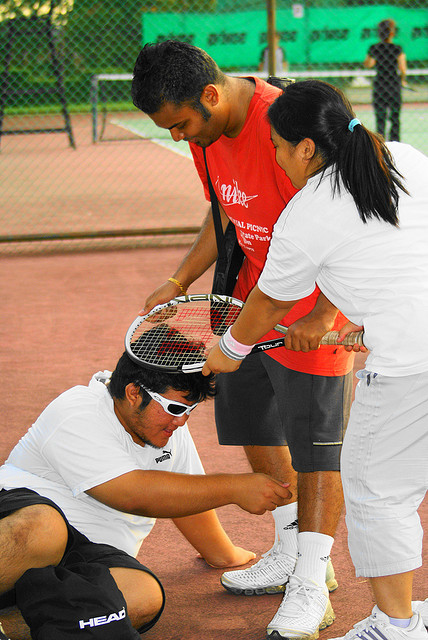Can you describe the setting and the mood of the image? The setting is an outdoor tennis court with a green surface, likely during a casual game or practice. The mood appears collaborative and supportive, with one individual receiving help with their equipment, which suggests a friendly and cooperative atmosphere. 